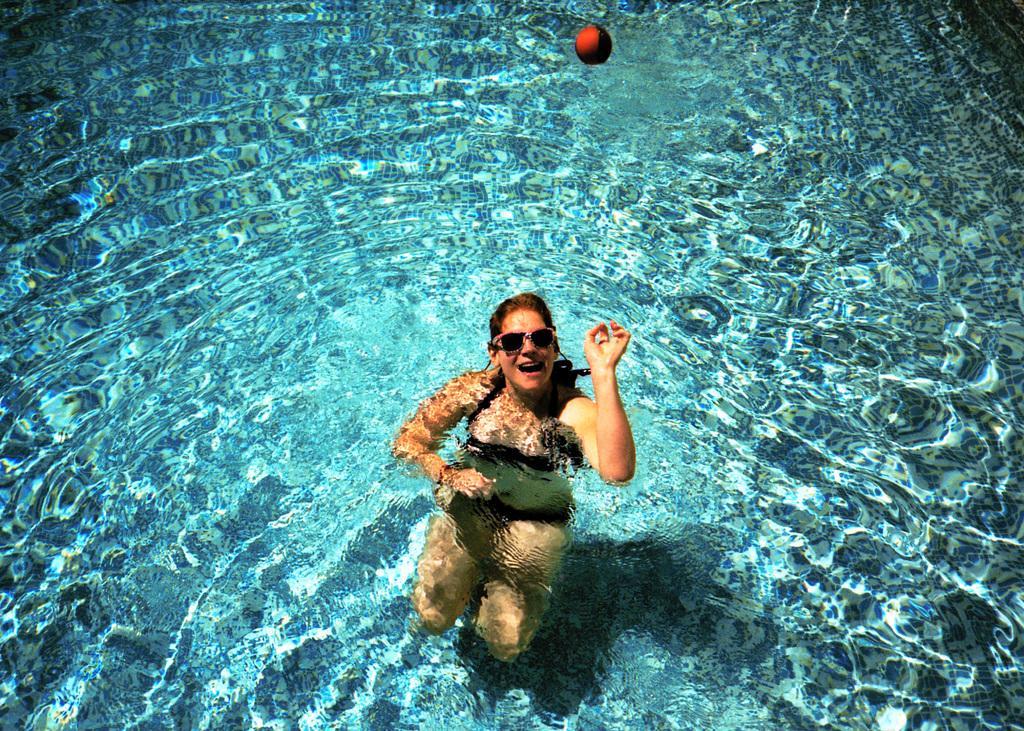Please provide a concise description of this image. In this picture we can observe a woman in the swimming pool. She is wearing spectacles. We can observe a red color ball in the water. 